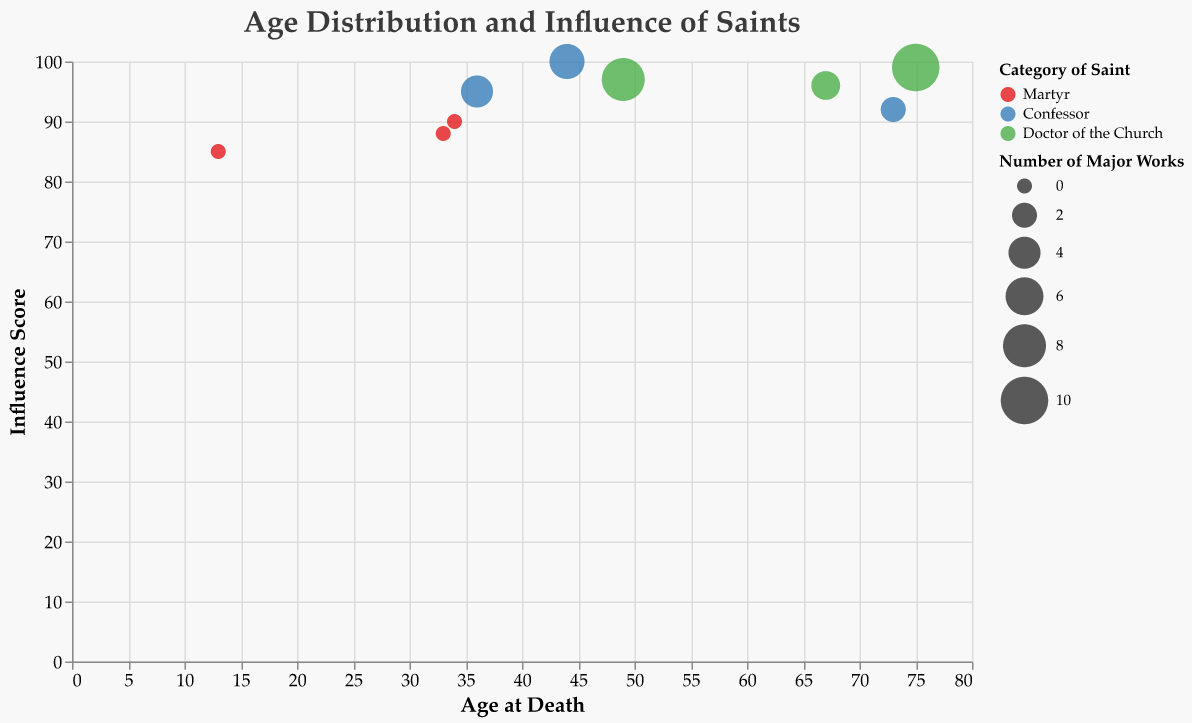How many categories of saints are displayed in the plot? The legend indicates there are three different categories of saints, each represented by a different color. They are Martyr, Confessor, and Doctor of the Church.
Answer: 3 Which saint has the highest Influence Score and what is it? The saint with the highest Influence Score is Saint Francis of Assisi, with a score of 100, as indicated by the position near the top of the y-axis and the tooltip.
Answer: Saint Francis of Assisi, 100 What is the age at death of the youngest martyr displayed in the chart? By checking the data points under the Martyr category, the youngest martyr is Saint Agnes who died at the age of 13, as shown by the tooltip when hovering over the smallest red bubble.
Answer: 13 How many saints died at an age of 49 or older? From the x-axis, the dots representing ages 49 or above are for Saint Thomas Aquinas (49), Saint John Vianney (73), Saint Augustine (75), and Saint Teresa of Ávila (67). That makes 4 saints.
Answer: 4 Compare the number of major works for the oldest and youngest saints in the chart. The oldest saint is Saint Augustine (75 years) and the youngest is Saint Agnes (13 years). Saint Augustine has 10 major works, and Saint Agnes has 0.
Answer: 10 and 0 What is the average Influence Score for the confessors? The Influence Scores for confessors are 95, 100, and 92. Calculate the average: (95 + 100 + 92)/3 = 287 / 3 ≈ 95.67.
Answer: 95.67 Which category of saints generally lived the longest according to the chart? By examining the x-axis positions, Doctors of the Church have the highest average ages (49, 75, 67) compared to Martyrs (13, 33, 34) and Confessors (36, 44, 73).
Answer: Doctor of the Church Is there a correlation between the number of major works and the Influence Score? By observing the sizes of the bubbles and their y-axis positions, generally, larger bubbles (more major works) have higher Influence Scores, indicating a positive correlation.
Answer: Yes 